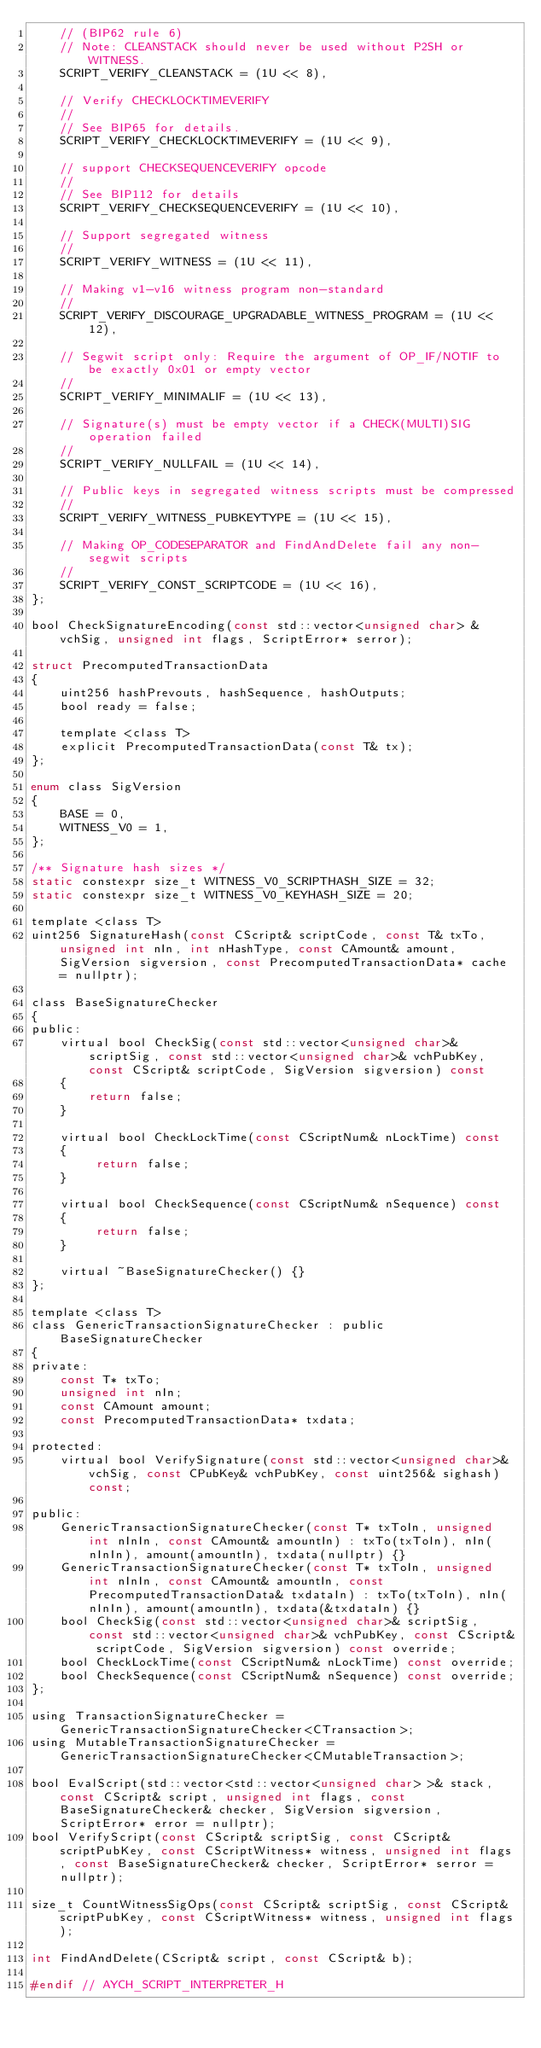Convert code to text. <code><loc_0><loc_0><loc_500><loc_500><_C_>    // (BIP62 rule 6)
    // Note: CLEANSTACK should never be used without P2SH or WITNESS.
    SCRIPT_VERIFY_CLEANSTACK = (1U << 8),

    // Verify CHECKLOCKTIMEVERIFY
    //
    // See BIP65 for details.
    SCRIPT_VERIFY_CHECKLOCKTIMEVERIFY = (1U << 9),

    // support CHECKSEQUENCEVERIFY opcode
    //
    // See BIP112 for details
    SCRIPT_VERIFY_CHECKSEQUENCEVERIFY = (1U << 10),

    // Support segregated witness
    //
    SCRIPT_VERIFY_WITNESS = (1U << 11),

    // Making v1-v16 witness program non-standard
    //
    SCRIPT_VERIFY_DISCOURAGE_UPGRADABLE_WITNESS_PROGRAM = (1U << 12),

    // Segwit script only: Require the argument of OP_IF/NOTIF to be exactly 0x01 or empty vector
    //
    SCRIPT_VERIFY_MINIMALIF = (1U << 13),

    // Signature(s) must be empty vector if a CHECK(MULTI)SIG operation failed
    //
    SCRIPT_VERIFY_NULLFAIL = (1U << 14),

    // Public keys in segregated witness scripts must be compressed
    //
    SCRIPT_VERIFY_WITNESS_PUBKEYTYPE = (1U << 15),

    // Making OP_CODESEPARATOR and FindAndDelete fail any non-segwit scripts
    //
    SCRIPT_VERIFY_CONST_SCRIPTCODE = (1U << 16),
};

bool CheckSignatureEncoding(const std::vector<unsigned char> &vchSig, unsigned int flags, ScriptError* serror);

struct PrecomputedTransactionData
{
    uint256 hashPrevouts, hashSequence, hashOutputs;
    bool ready = false;

    template <class T>
    explicit PrecomputedTransactionData(const T& tx);
};

enum class SigVersion
{
    BASE = 0,
    WITNESS_V0 = 1,
};

/** Signature hash sizes */
static constexpr size_t WITNESS_V0_SCRIPTHASH_SIZE = 32;
static constexpr size_t WITNESS_V0_KEYHASH_SIZE = 20;

template <class T>
uint256 SignatureHash(const CScript& scriptCode, const T& txTo, unsigned int nIn, int nHashType, const CAmount& amount, SigVersion sigversion, const PrecomputedTransactionData* cache = nullptr);

class BaseSignatureChecker
{
public:
    virtual bool CheckSig(const std::vector<unsigned char>& scriptSig, const std::vector<unsigned char>& vchPubKey, const CScript& scriptCode, SigVersion sigversion) const
    {
        return false;
    }

    virtual bool CheckLockTime(const CScriptNum& nLockTime) const
    {
         return false;
    }

    virtual bool CheckSequence(const CScriptNum& nSequence) const
    {
         return false;
    }

    virtual ~BaseSignatureChecker() {}
};

template <class T>
class GenericTransactionSignatureChecker : public BaseSignatureChecker
{
private:
    const T* txTo;
    unsigned int nIn;
    const CAmount amount;
    const PrecomputedTransactionData* txdata;

protected:
    virtual bool VerifySignature(const std::vector<unsigned char>& vchSig, const CPubKey& vchPubKey, const uint256& sighash) const;

public:
    GenericTransactionSignatureChecker(const T* txToIn, unsigned int nInIn, const CAmount& amountIn) : txTo(txToIn), nIn(nInIn), amount(amountIn), txdata(nullptr) {}
    GenericTransactionSignatureChecker(const T* txToIn, unsigned int nInIn, const CAmount& amountIn, const PrecomputedTransactionData& txdataIn) : txTo(txToIn), nIn(nInIn), amount(amountIn), txdata(&txdataIn) {}
    bool CheckSig(const std::vector<unsigned char>& scriptSig, const std::vector<unsigned char>& vchPubKey, const CScript& scriptCode, SigVersion sigversion) const override;
    bool CheckLockTime(const CScriptNum& nLockTime) const override;
    bool CheckSequence(const CScriptNum& nSequence) const override;
};

using TransactionSignatureChecker = GenericTransactionSignatureChecker<CTransaction>;
using MutableTransactionSignatureChecker = GenericTransactionSignatureChecker<CMutableTransaction>;

bool EvalScript(std::vector<std::vector<unsigned char> >& stack, const CScript& script, unsigned int flags, const BaseSignatureChecker& checker, SigVersion sigversion, ScriptError* error = nullptr);
bool VerifyScript(const CScript& scriptSig, const CScript& scriptPubKey, const CScriptWitness* witness, unsigned int flags, const BaseSignatureChecker& checker, ScriptError* serror = nullptr);

size_t CountWitnessSigOps(const CScript& scriptSig, const CScript& scriptPubKey, const CScriptWitness* witness, unsigned int flags);

int FindAndDelete(CScript& script, const CScript& b);

#endif // AYCH_SCRIPT_INTERPRETER_H
</code> 